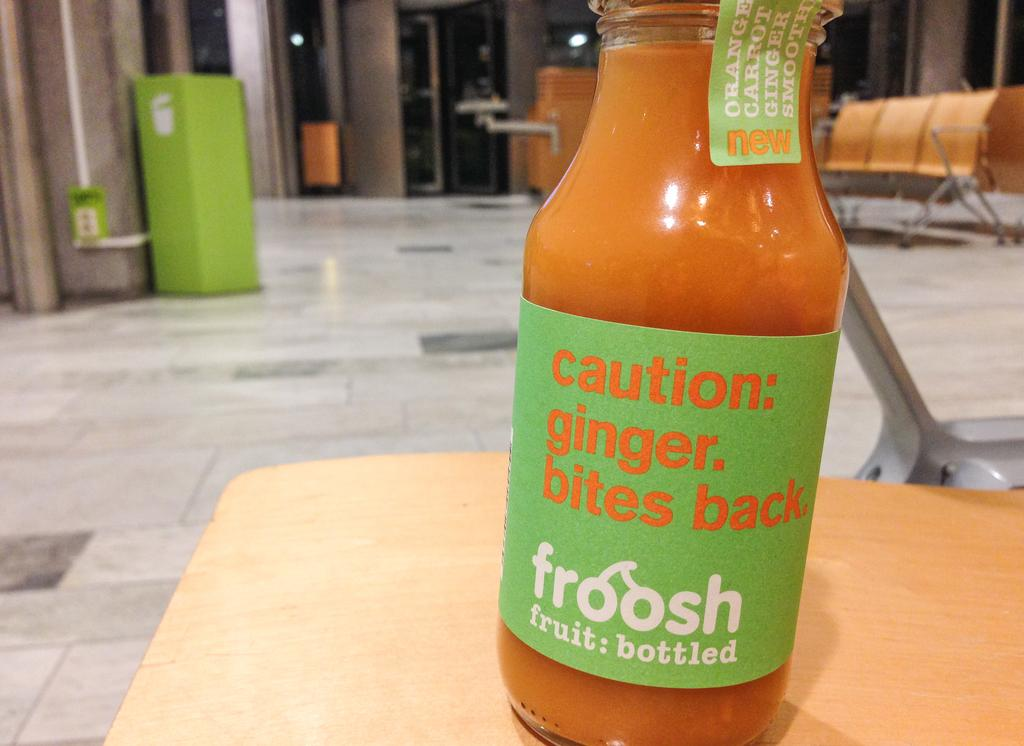<image>
Share a concise interpretation of the image provided. The froosh (fruit: bottled) new orange, carrot, and ginger smoothie includes a "caution: ginger. bites back."! 